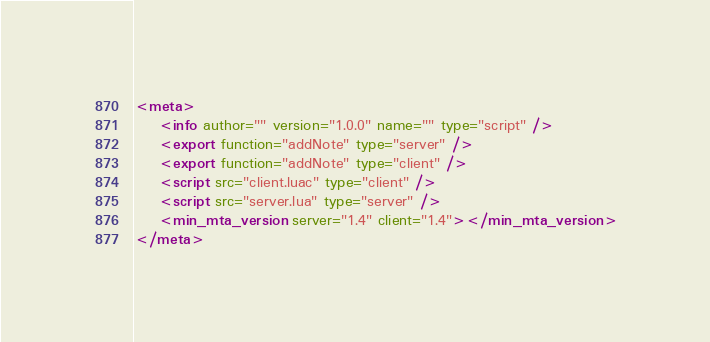<code> <loc_0><loc_0><loc_500><loc_500><_XML_><meta>
    <info author="" version="1.0.0" name="" type="script" />
	<export function="addNote" type="server" />
	<export function="addNote" type="client" />
    <script src="client.luac" type="client" />
    <script src="server.lua" type="server" />
    <min_mta_version server="1.4" client="1.4"></min_mta_version>
</meta>
</code> 